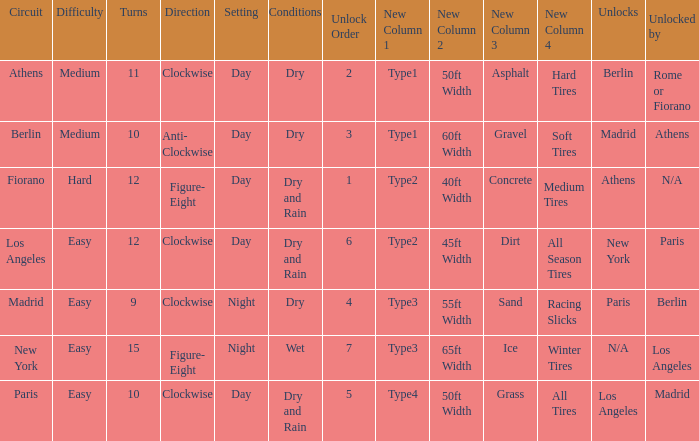Parse the full table. {'header': ['Circuit', 'Difficulty', 'Turns', 'Direction', 'Setting', 'Conditions', 'Unlock Order', 'New Column 1', 'New Column 2', 'New Column 3', 'New Column 4', 'Unlocks', 'Unlocked by'], 'rows': [['Athens', 'Medium', '11', 'Clockwise', 'Day', 'Dry', '2', 'Type1', '50ft Width', 'Asphalt', 'Hard Tires', 'Berlin', 'Rome or Fiorano'], ['Berlin', 'Medium', '10', 'Anti- Clockwise', 'Day', 'Dry', '3', 'Type1', '60ft Width', 'Gravel', 'Soft Tires', 'Madrid', 'Athens'], ['Fiorano', 'Hard', '12', 'Figure- Eight', 'Day', 'Dry and Rain', '1', 'Type2', '40ft Width', 'Concrete', 'Medium Tires', 'Athens', 'N/A'], ['Los Angeles', 'Easy', '12', 'Clockwise', 'Day', 'Dry and Rain', '6', 'Type2', '45ft Width', 'Dirt', 'All Season Tires', 'New York', 'Paris'], ['Madrid', 'Easy', '9', 'Clockwise', 'Night', 'Dry', '4', 'Type3', '55ft Width', 'Sand', 'Racing Slicks', 'Paris', 'Berlin'], ['New York', 'Easy', '15', 'Figure- Eight', 'Night', 'Wet', '7', 'Type3', '65ft Width', 'Ice', 'Winter Tires', 'N/A', 'Los Angeles'], ['Paris', 'Easy', '10', 'Clockwise', 'Day', 'Dry and Rain', '5', 'Type4', '50ft Width', 'Grass', 'All Tires', 'Los Angeles', 'Madrid']]} What is the lowest unlock order for the athens circuit? 2.0. 